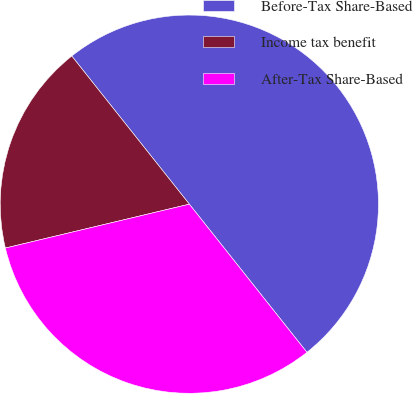<chart> <loc_0><loc_0><loc_500><loc_500><pie_chart><fcel>Before-Tax Share-Based<fcel>Income tax benefit<fcel>After-Tax Share-Based<nl><fcel>50.0%<fcel>18.05%<fcel>31.95%<nl></chart> 